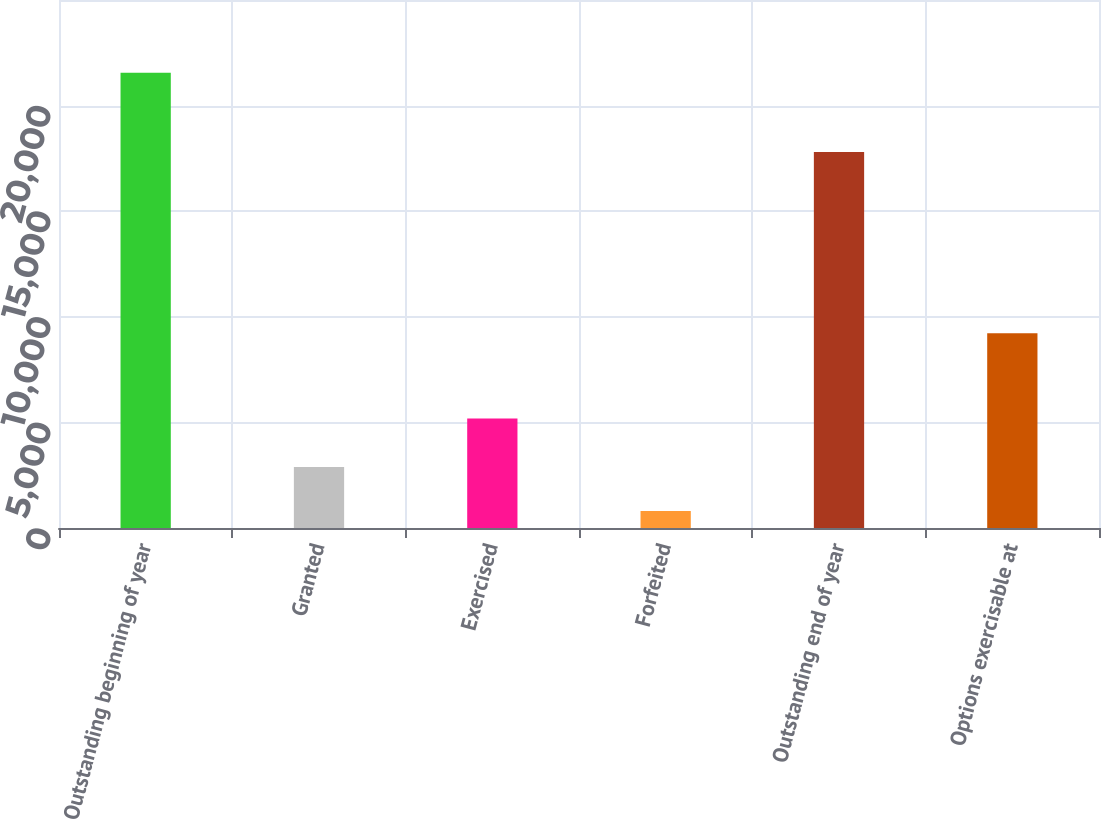Convert chart. <chart><loc_0><loc_0><loc_500><loc_500><bar_chart><fcel>Outstanding beginning of year<fcel>Granted<fcel>Exercised<fcel>Forfeited<fcel>Outstanding end of year<fcel>Options exercisable at<nl><fcel>21554<fcel>2883.5<fcel>5181<fcel>809<fcel>17802<fcel>9220<nl></chart> 